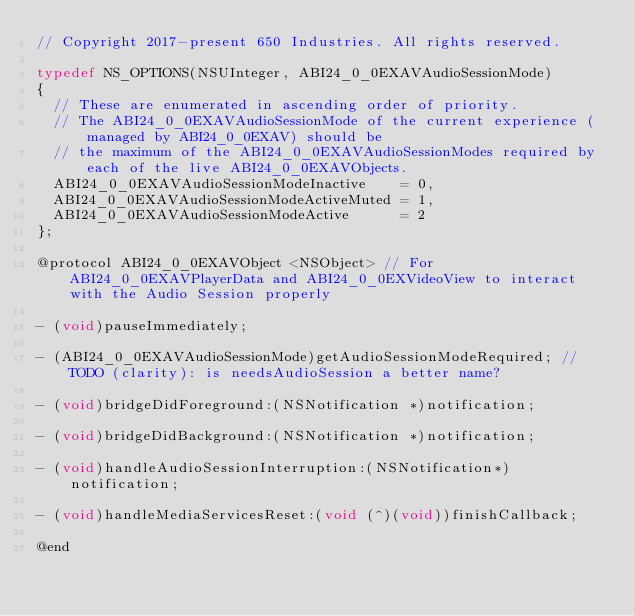<code> <loc_0><loc_0><loc_500><loc_500><_C_>// Copyright 2017-present 650 Industries. All rights reserved.

typedef NS_OPTIONS(NSUInteger, ABI24_0_0EXAVAudioSessionMode)
{
  // These are enumerated in ascending order of priority.
  // The ABI24_0_0EXAVAudioSessionMode of the current experience (managed by ABI24_0_0EXAV) should be
  // the maximum of the ABI24_0_0EXAVAudioSessionModes required by each of the live ABI24_0_0EXAVObjects.
  ABI24_0_0EXAVAudioSessionModeInactive    = 0,
  ABI24_0_0EXAVAudioSessionModeActiveMuted = 1,
  ABI24_0_0EXAVAudioSessionModeActive      = 2
};

@protocol ABI24_0_0EXAVObject <NSObject> // For ABI24_0_0EXAVPlayerData and ABI24_0_0EXVideoView to interact with the Audio Session properly

- (void)pauseImmediately;

- (ABI24_0_0EXAVAudioSessionMode)getAudioSessionModeRequired; // TODO (clarity): is needsAudioSession a better name?

- (void)bridgeDidForeground:(NSNotification *)notification;

- (void)bridgeDidBackground:(NSNotification *)notification;

- (void)handleAudioSessionInterruption:(NSNotification*)notification;

- (void)handleMediaServicesReset:(void (^)(void))finishCallback;

@end
</code> 